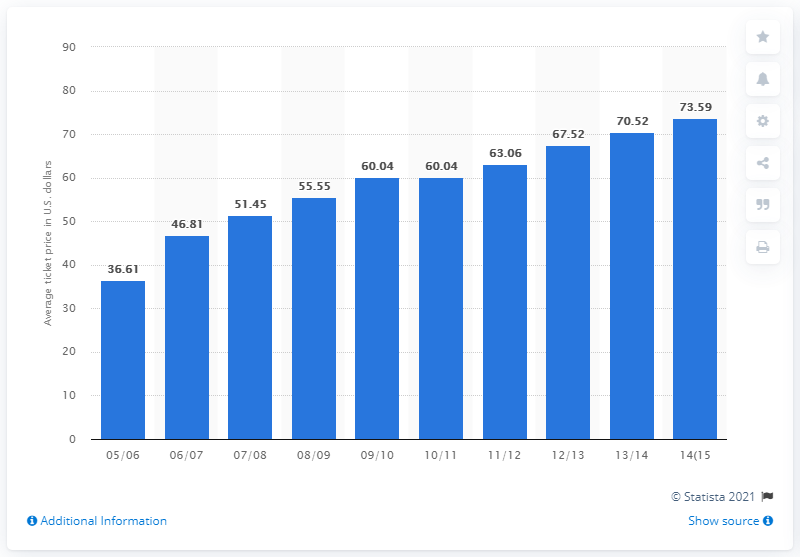Draw attention to some important aspects in this diagram. The average ticket price for Pittsburgh Penguins games in the 2005/2006 season was 36.61. 